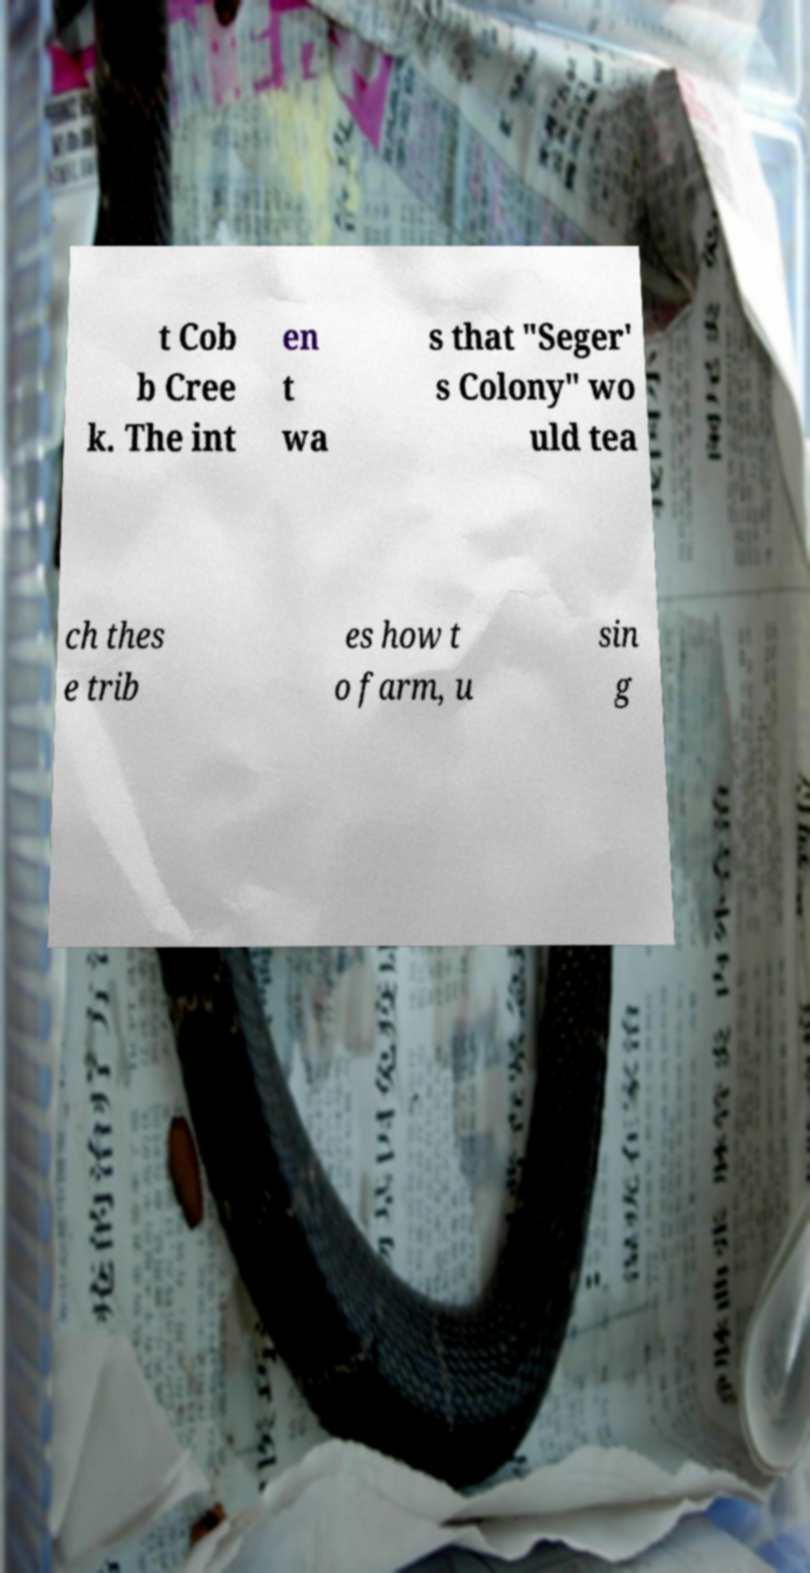Can you read and provide the text displayed in the image?This photo seems to have some interesting text. Can you extract and type it out for me? t Cob b Cree k. The int en t wa s that "Seger' s Colony" wo uld tea ch thes e trib es how t o farm, u sin g 